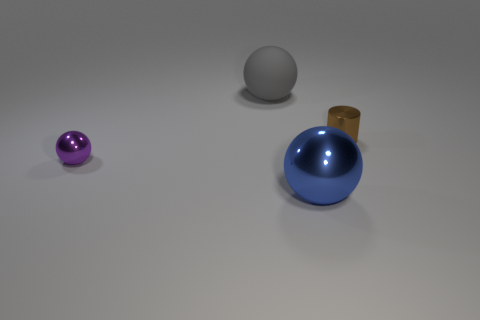Subtract all gray matte balls. How many balls are left? 2 Add 2 big yellow metallic objects. How many objects exist? 6 Subtract all spheres. How many objects are left? 1 Subtract 1 cylinders. How many cylinders are left? 0 Add 3 large brown cylinders. How many large brown cylinders exist? 3 Subtract 0 gray cylinders. How many objects are left? 4 Subtract all green spheres. Subtract all cyan blocks. How many spheres are left? 3 Subtract all cyan blocks. How many purple spheres are left? 1 Subtract all tiny purple shiny blocks. Subtract all large blue metal objects. How many objects are left? 3 Add 2 blue metal things. How many blue metal things are left? 3 